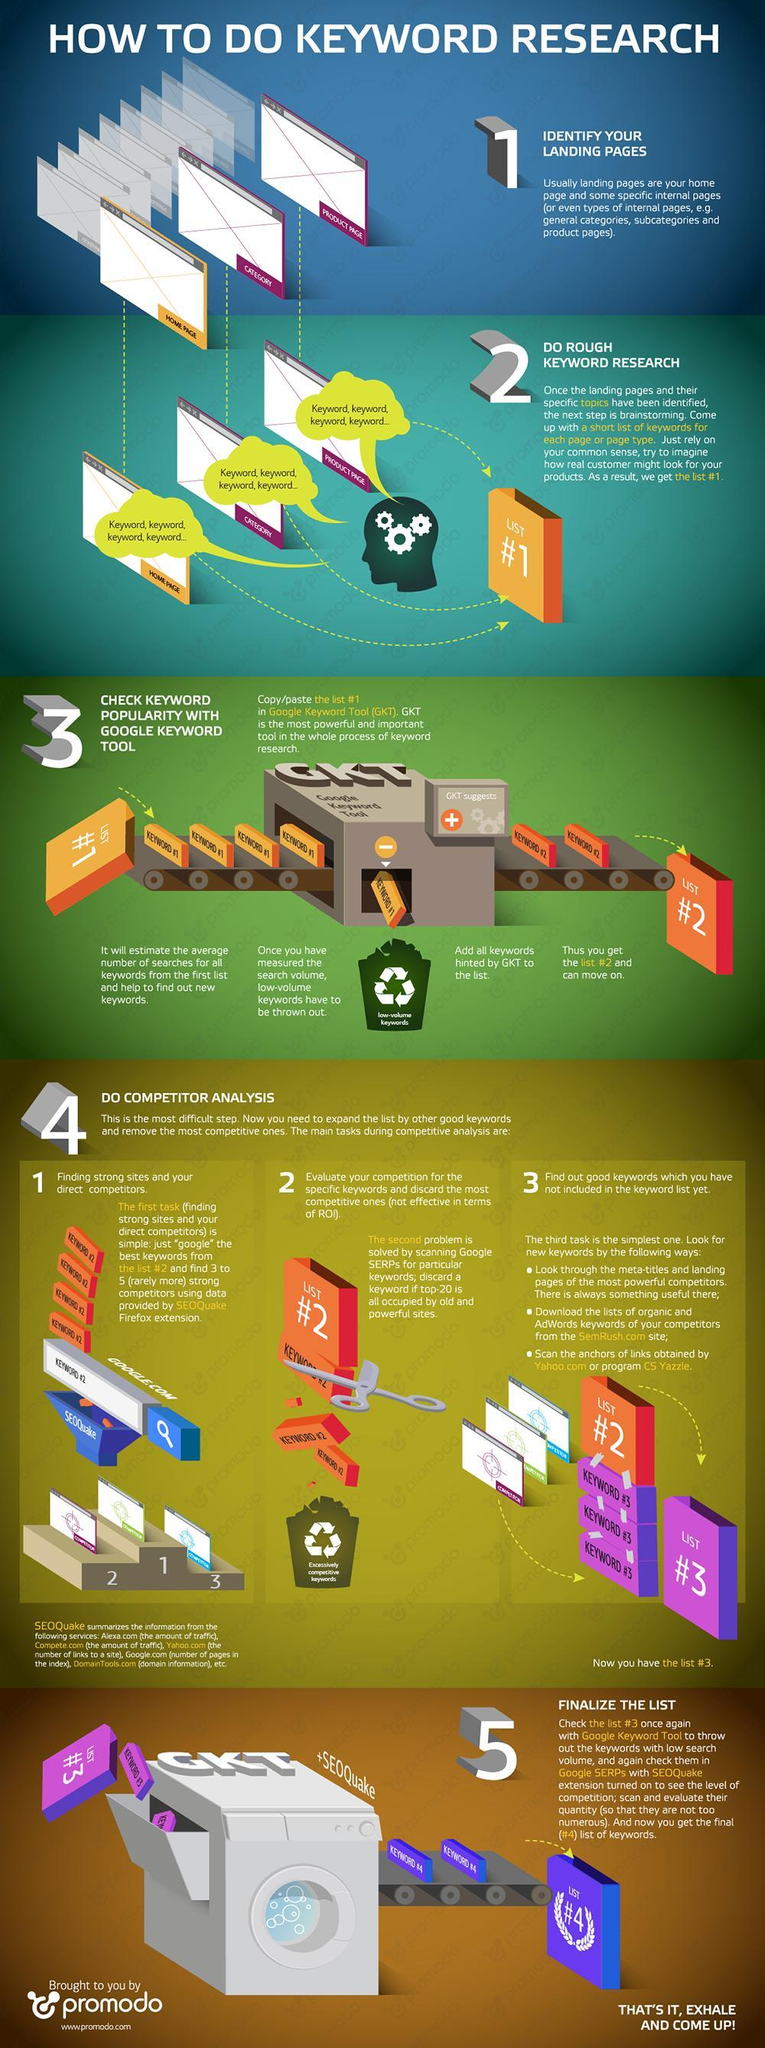How many points are under the heading "Do competitor analysis"?
Answer the question with a short phrase. 3 